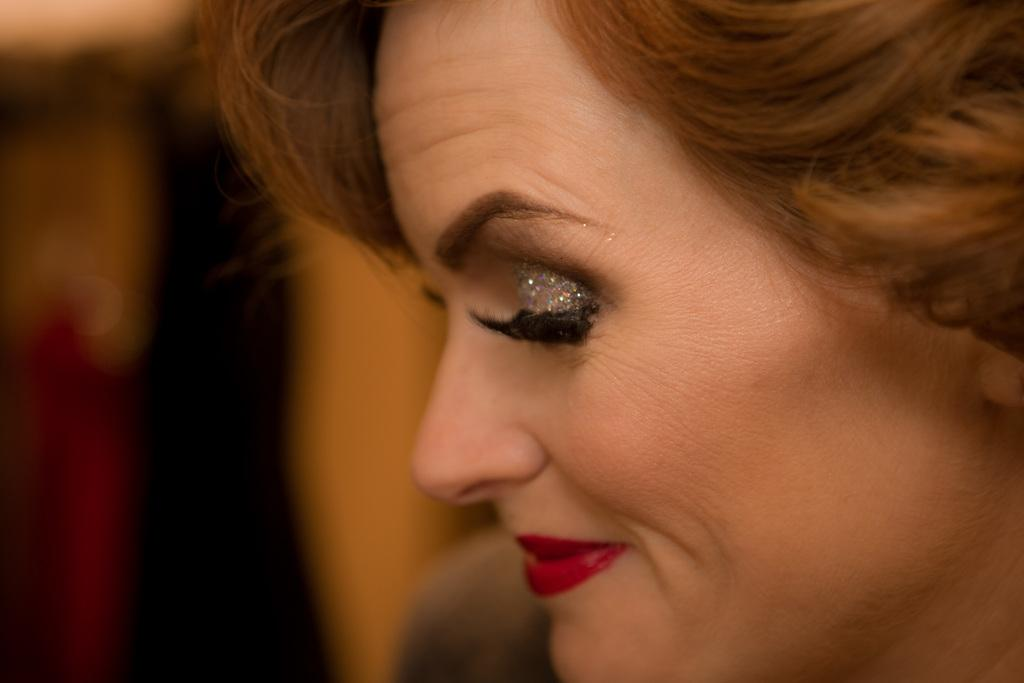Who is the main subject in the image? There is a lady in the image. What makeup detail can be observed on the lady? The lady has glitter eyeshadow. Can you describe the background of the image? The background of the image is blurred. What type of spy equipment can be seen in the lady's hand in the image? There is no spy equipment visible in the lady's hand in the image. What things does the lady have in her possession in the image? The provided facts do not mention any specific things the lady has in her possession. 